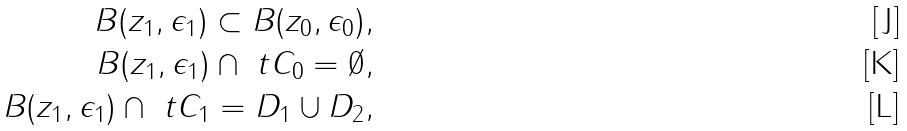Convert formula to latex. <formula><loc_0><loc_0><loc_500><loc_500>B ( z _ { 1 } , \epsilon _ { 1 } ) \subset B ( z _ { 0 } , \epsilon _ { 0 } ) , \\ B ( z _ { 1 } , \epsilon _ { 1 } ) \cap \ t C _ { 0 } = \emptyset , \\ B ( z _ { 1 } , \epsilon _ { 1 } ) \cap \ t C _ { 1 } = D _ { 1 } \cup D _ { 2 } ,</formula> 